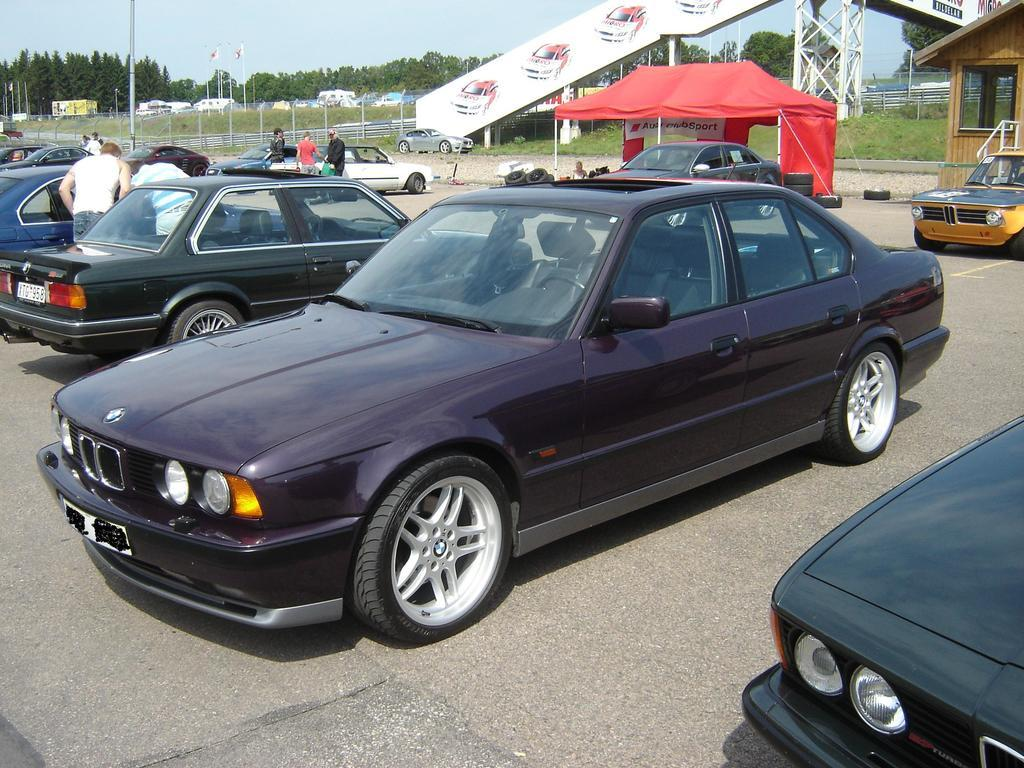What can be seen on the road in the image? There are cars on the road in the image. What is visible in the background of the image? In the background of the image, there is a house, cars, a tent, fencing, flags, poles, trees, and the sky. What type of attack can be seen happening in the image? There is no attack present in the image; it features cars on the road and various objects in the background. How many horses are visible in the image? There are no horses present in the image. 